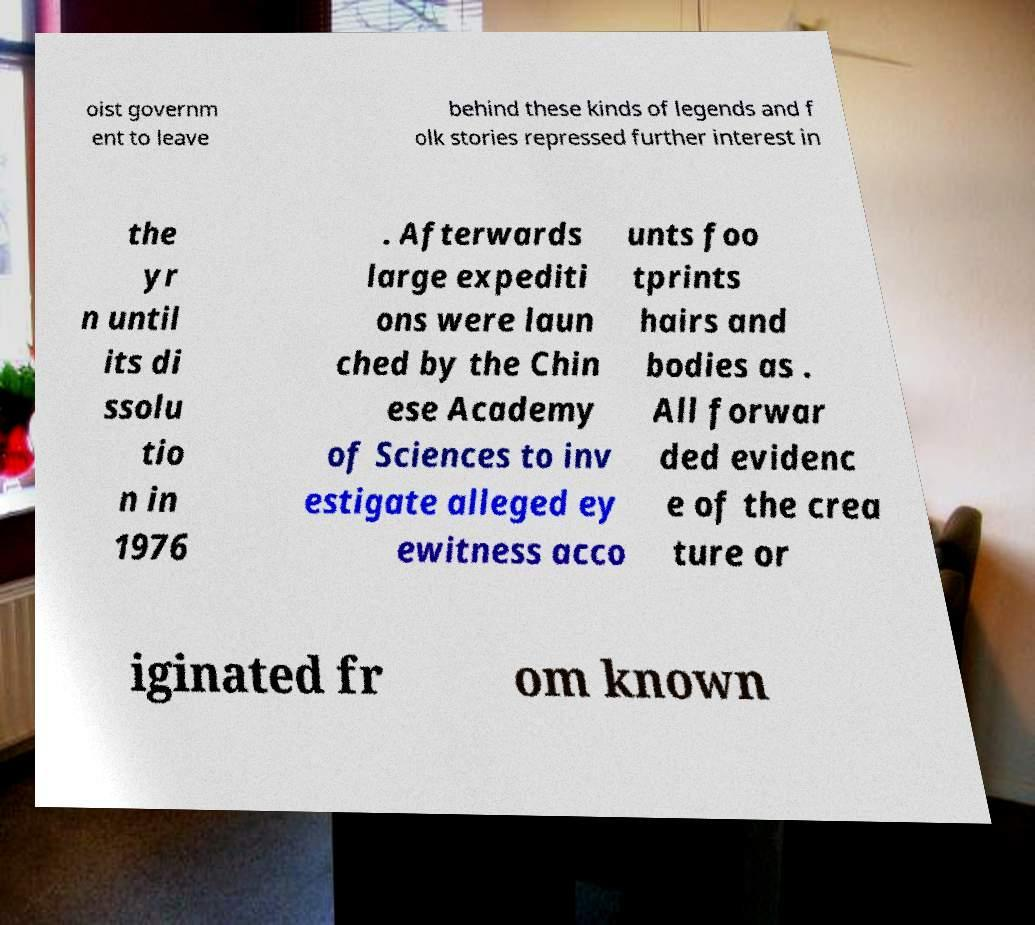Can you accurately transcribe the text from the provided image for me? oist governm ent to leave behind these kinds of legends and f olk stories repressed further interest in the yr n until its di ssolu tio n in 1976 . Afterwards large expediti ons were laun ched by the Chin ese Academy of Sciences to inv estigate alleged ey ewitness acco unts foo tprints hairs and bodies as . All forwar ded evidenc e of the crea ture or iginated fr om known 